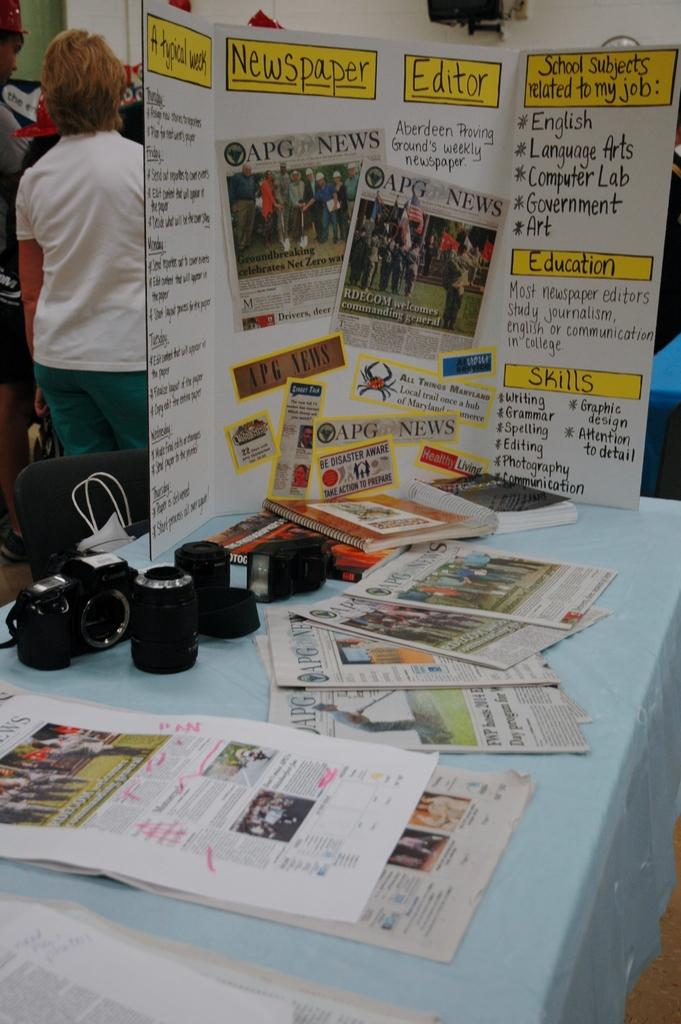<image>
Offer a succinct explanation of the picture presented. A large poster standing up with information about A typical week for a Newspaper Editor 